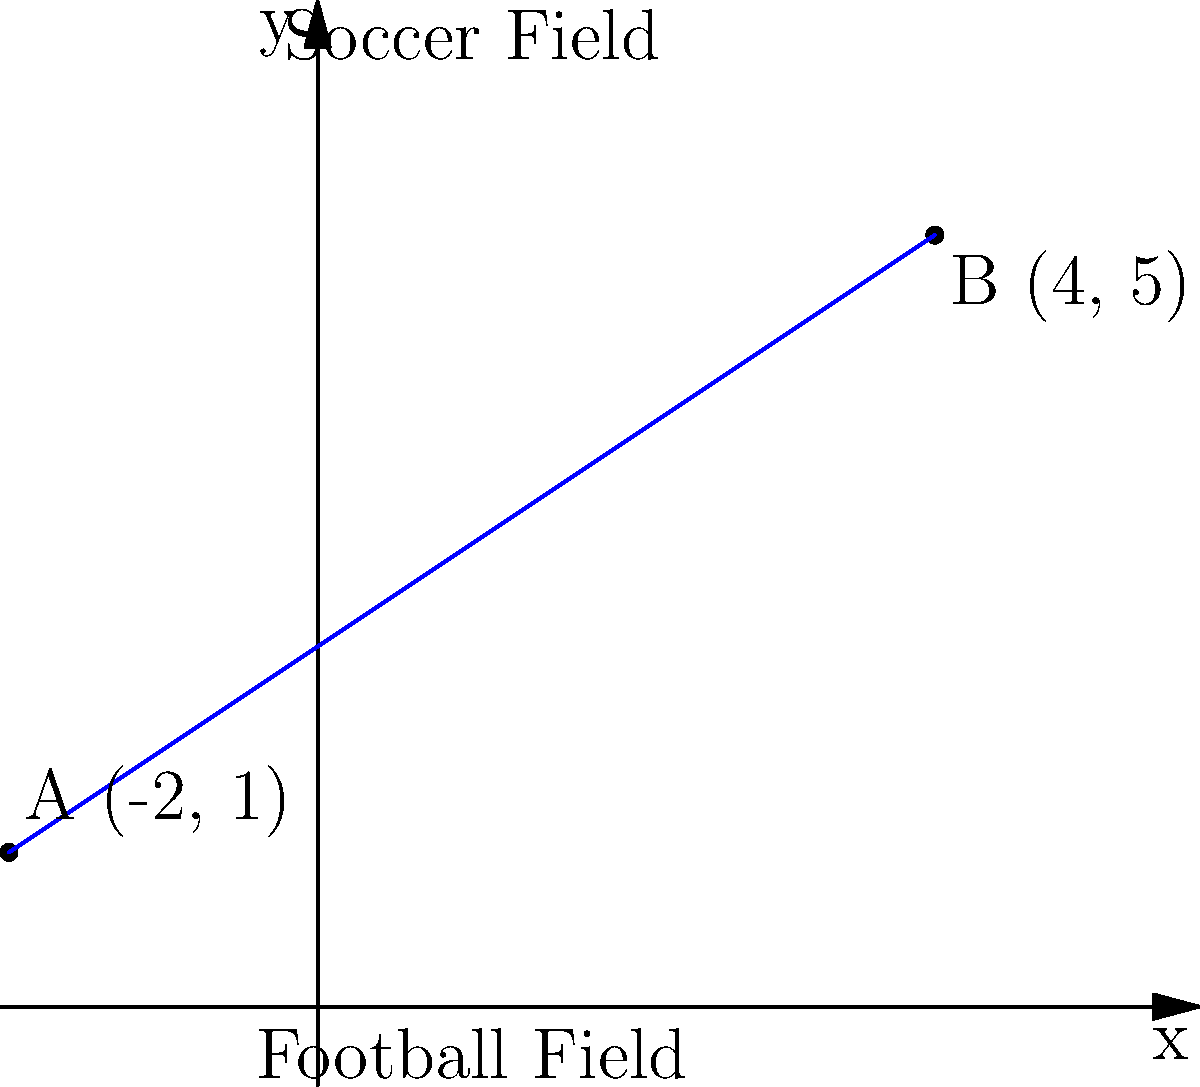An athlete is transitioning between a football field and a soccer field. Their starting position on the football field is represented by point A (-2, 1), and their ending position on the soccer field is represented by point B (4, 5). Find the equation of the line representing the athlete's movement trajectory in slope-intercept form $(y = mx + b)$. To find the equation of the line passing through two points, we can follow these steps:

1. Calculate the slope $(m)$ using the slope formula:
   $m = \frac{y_2 - y_1}{x_2 - x_1} = \frac{5 - 1}{4 - (-2)} = \frac{4}{6} = \frac{2}{3}$

2. Use the point-slope form of a line $(y - y_1 = m(x - x_1))$ with either point. Let's use point A (-2, 1):
   $y - 1 = \frac{2}{3}(x - (-2))$

3. Simplify the equation:
   $y - 1 = \frac{2}{3}(x + 2)$
   $y - 1 = \frac{2}{3}x + \frac{4}{3}$

4. Rearrange to slope-intercept form $(y = mx + b)$:
   $y = \frac{2}{3}x + \frac{4}{3} + 1$
   $y = \frac{2}{3}x + \frac{7}{3}$

Therefore, the equation of the line representing the athlete's movement trajectory in slope-intercept form is $y = \frac{2}{3}x + \frac{7}{3}$.
Answer: $y = \frac{2}{3}x + \frac{7}{3}$ 